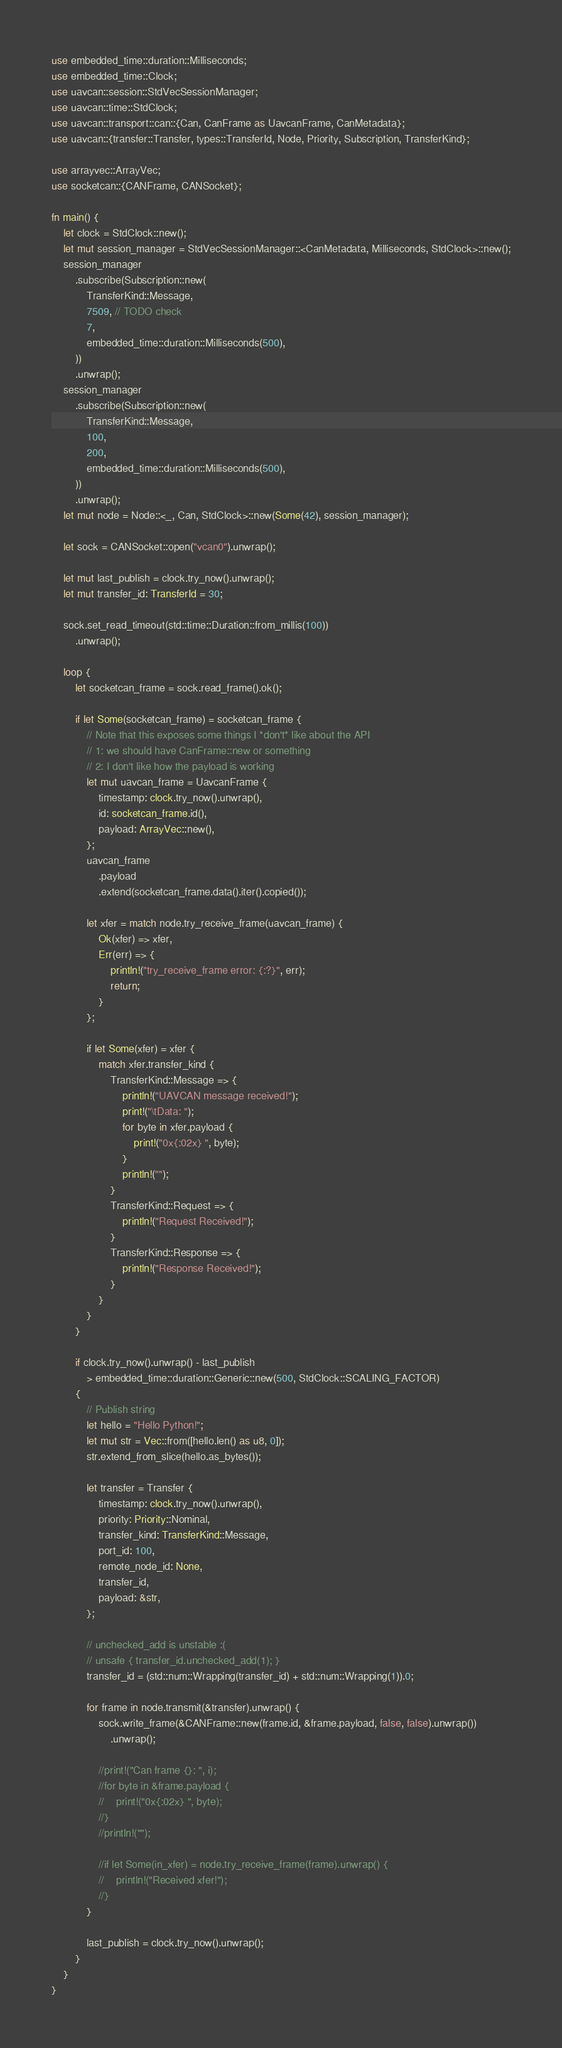Convert code to text. <code><loc_0><loc_0><loc_500><loc_500><_Rust_>use embedded_time::duration::Milliseconds;
use embedded_time::Clock;
use uavcan::session::StdVecSessionManager;
use uavcan::time::StdClock;
use uavcan::transport::can::{Can, CanFrame as UavcanFrame, CanMetadata};
use uavcan::{transfer::Transfer, types::TransferId, Node, Priority, Subscription, TransferKind};

use arrayvec::ArrayVec;
use socketcan::{CANFrame, CANSocket};

fn main() {
    let clock = StdClock::new();
    let mut session_manager = StdVecSessionManager::<CanMetadata, Milliseconds, StdClock>::new();
    session_manager
        .subscribe(Subscription::new(
            TransferKind::Message,
            7509, // TODO check
            7,
            embedded_time::duration::Milliseconds(500),
        ))
        .unwrap();
    session_manager
        .subscribe(Subscription::new(
            TransferKind::Message,
            100,
            200,
            embedded_time::duration::Milliseconds(500),
        ))
        .unwrap();
    let mut node = Node::<_, Can, StdClock>::new(Some(42), session_manager);

    let sock = CANSocket::open("vcan0").unwrap();

    let mut last_publish = clock.try_now().unwrap();
    let mut transfer_id: TransferId = 30;

    sock.set_read_timeout(std::time::Duration::from_millis(100))
        .unwrap();

    loop {
        let socketcan_frame = sock.read_frame().ok();

        if let Some(socketcan_frame) = socketcan_frame {
            // Note that this exposes some things I *don't* like about the API
            // 1: we should have CanFrame::new or something
            // 2: I don't like how the payload is working
            let mut uavcan_frame = UavcanFrame {
                timestamp: clock.try_now().unwrap(),
                id: socketcan_frame.id(),
                payload: ArrayVec::new(),
            };
            uavcan_frame
                .payload
                .extend(socketcan_frame.data().iter().copied());

            let xfer = match node.try_receive_frame(uavcan_frame) {
                Ok(xfer) => xfer,
                Err(err) => {
                    println!("try_receive_frame error: {:?}", err);
                    return;
                }
            };

            if let Some(xfer) = xfer {
                match xfer.transfer_kind {
                    TransferKind::Message => {
                        println!("UAVCAN message received!");
                        print!("\tData: ");
                        for byte in xfer.payload {
                            print!("0x{:02x} ", byte);
                        }
                        println!("");
                    }
                    TransferKind::Request => {
                        println!("Request Received!");
                    }
                    TransferKind::Response => {
                        println!("Response Received!");
                    }
                }
            }
        }

        if clock.try_now().unwrap() - last_publish
            > embedded_time::duration::Generic::new(500, StdClock::SCALING_FACTOR)
        {
            // Publish string
            let hello = "Hello Python!";
            let mut str = Vec::from([hello.len() as u8, 0]);
            str.extend_from_slice(hello.as_bytes());

            let transfer = Transfer {
                timestamp: clock.try_now().unwrap(),
                priority: Priority::Nominal,
                transfer_kind: TransferKind::Message,
                port_id: 100,
                remote_node_id: None,
                transfer_id,
                payload: &str,
            };

            // unchecked_add is unstable :(
            // unsafe { transfer_id.unchecked_add(1); }
            transfer_id = (std::num::Wrapping(transfer_id) + std::num::Wrapping(1)).0;

            for frame in node.transmit(&transfer).unwrap() {
                sock.write_frame(&CANFrame::new(frame.id, &frame.payload, false, false).unwrap())
                    .unwrap();

                //print!("Can frame {}: ", i);
                //for byte in &frame.payload {
                //    print!("0x{:02x} ", byte);
                //}
                //println!("");

                //if let Some(in_xfer) = node.try_receive_frame(frame).unwrap() {
                //    println!("Received xfer!");
                //}
            }

            last_publish = clock.try_now().unwrap();
        }
    }
}
</code> 